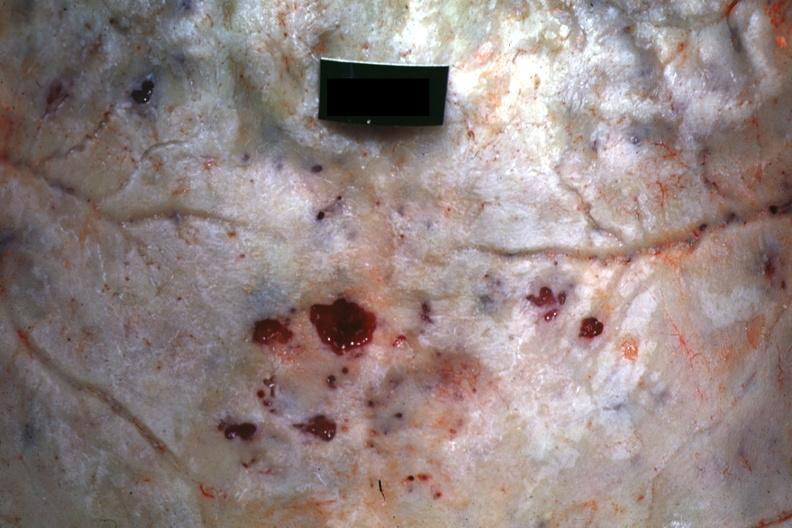what does this image show?
Answer the question using a single word or phrase. Close-up view of hemorrhagic excavation quite good 